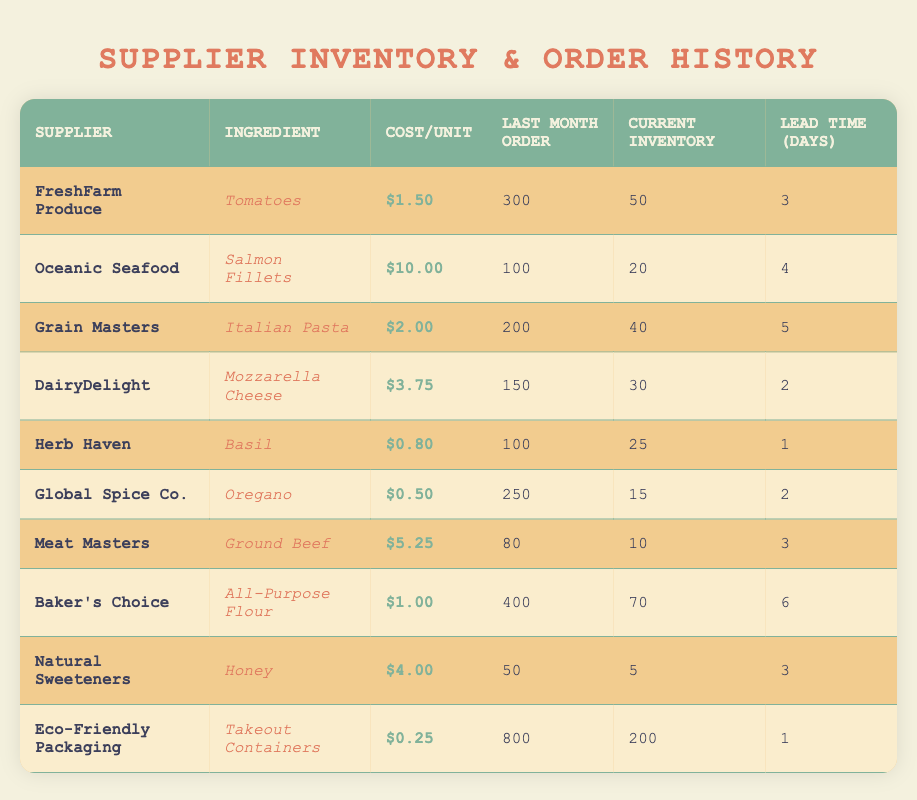What is the cost per unit of Ground Beef? The table shows the line for Ground Beef supplied by Meat Masters. The cost per unit for Ground Beef is explicitly stated as $5.25.
Answer: $5.25 How many units of Oregano were ordered last month? The table indicates that last month's order for Oregano, supplied by Global Spice Co., is listed as 250 units.
Answer: 250 units What is the total cost to order 300 units of Tomatoes? To find the total cost, multiply the cost per unit of Tomatoes ($1.50) by the number of units (300). The calculation is $1.50 * 300 = $450.
Answer: $450 Which ingredient has the lowest cost per unit? Scan through the cost per unit column to find the lowest. Oregano from Global Spice Co. is priced at $0.50, which is lower than all other ingredients.
Answer: Oregano Is the current inventory of Honey sufficient if we need to prepare for a large event? The current inventory of Honey is only 5 units. If planning for a large event, this inventory may not be sufficient, as we typically need larger quantities for events.
Answer: No What is the lead time for the ingredient with the highest cost per unit? Identify the ingredient with the highest cost per unit, which is Salmon Fillets at $10.00 from Oceanic Seafood. The lead time for this ingredient is 4 days.
Answer: 4 days How many units of All-Purpose Flour are currently in stock? The table shows that the current inventory for All-Purpose Flour, supplied by Baker's Choice, is reported as 70 units.
Answer: 70 units If I wanted to order 200 units of Mozzarella Cheese, what would the total cost be? The cost per unit of Mozzarella Cheese is $3.75. Therefore, the total cost for 200 units would be $3.75 * 200 = $750.
Answer: $750 What is the average cost per unit of the ingredients listed from FreshFarm Produce? There is one ingredient, Tomatoes, under FreshFarm Produce priced at $1.50. Since there's only one value, the average cost per unit is $1.50.
Answer: $1.50 Which supplier has the highest number of units ordered last month? Eco-Friendly Packaging ordered 800 units, which is the highest compared to other suppliers like FreshFarm Produce (300) and others.
Answer: Eco-Friendly Packaging What is the current inventory of Salmon Fillets and how does it compare to Ground Beef’s inventory? The current inventory for Salmon Fillets is 20 units, while Ground Beef has only 10 units in stock. Thus, Salmon Fillets have more inventory in comparison.
Answer: Salmon Fillets have more inventory 